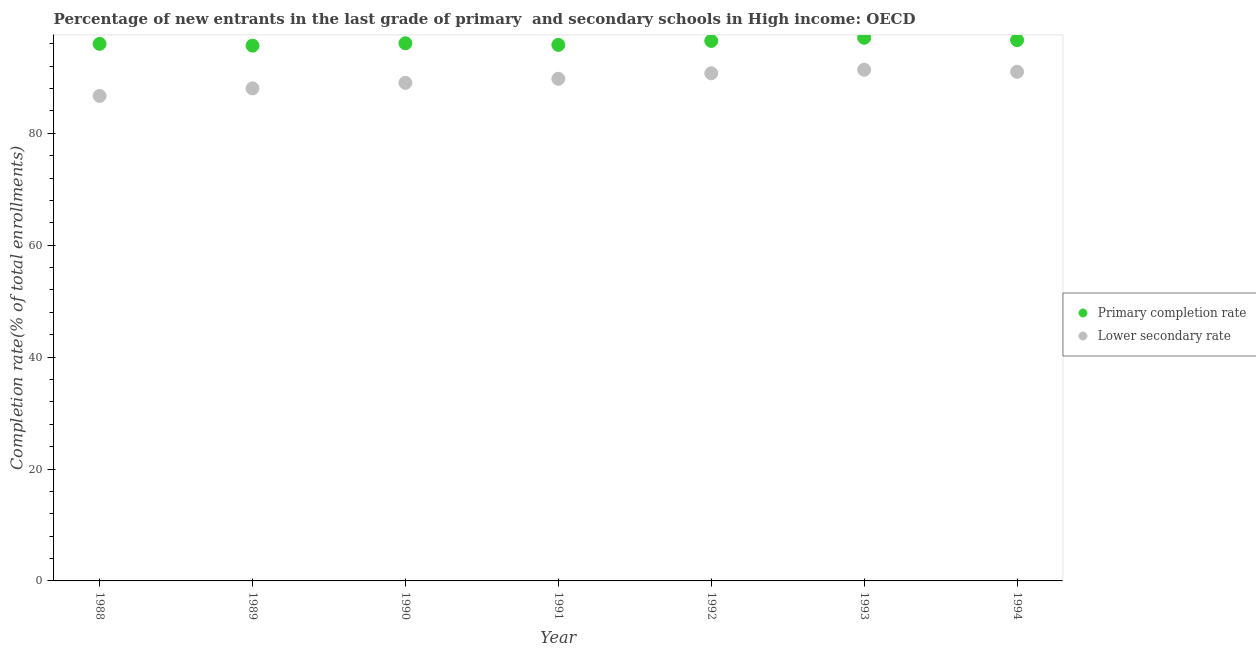What is the completion rate in primary schools in 1989?
Offer a very short reply. 95.66. Across all years, what is the maximum completion rate in secondary schools?
Offer a terse response. 91.36. Across all years, what is the minimum completion rate in primary schools?
Ensure brevity in your answer.  95.66. In which year was the completion rate in primary schools maximum?
Keep it short and to the point. 1993. What is the total completion rate in primary schools in the graph?
Your response must be concise. 673.74. What is the difference between the completion rate in primary schools in 1988 and that in 1992?
Your answer should be very brief. -0.52. What is the difference between the completion rate in primary schools in 1993 and the completion rate in secondary schools in 1990?
Your response must be concise. 8.06. What is the average completion rate in secondary schools per year?
Your answer should be compact. 89.5. In the year 1990, what is the difference between the completion rate in secondary schools and completion rate in primary schools?
Your response must be concise. -7.08. What is the ratio of the completion rate in primary schools in 1989 to that in 1993?
Make the answer very short. 0.99. Is the completion rate in secondary schools in 1990 less than that in 1992?
Your answer should be compact. Yes. Is the difference between the completion rate in secondary schools in 1991 and 1992 greater than the difference between the completion rate in primary schools in 1991 and 1992?
Offer a terse response. No. What is the difference between the highest and the second highest completion rate in primary schools?
Ensure brevity in your answer.  0.42. What is the difference between the highest and the lowest completion rate in secondary schools?
Provide a short and direct response. 4.68. In how many years, is the completion rate in primary schools greater than the average completion rate in primary schools taken over all years?
Your answer should be very brief. 3. Is the sum of the completion rate in primary schools in 1988 and 1989 greater than the maximum completion rate in secondary schools across all years?
Give a very brief answer. Yes. Does the completion rate in primary schools monotonically increase over the years?
Your response must be concise. No. Is the completion rate in primary schools strictly less than the completion rate in secondary schools over the years?
Ensure brevity in your answer.  No. How many dotlines are there?
Make the answer very short. 2. What is the difference between two consecutive major ticks on the Y-axis?
Provide a succinct answer. 20. Does the graph contain any zero values?
Give a very brief answer. No. Does the graph contain grids?
Ensure brevity in your answer.  No. How many legend labels are there?
Your response must be concise. 2. How are the legend labels stacked?
Provide a short and direct response. Vertical. What is the title of the graph?
Provide a short and direct response. Percentage of new entrants in the last grade of primary  and secondary schools in High income: OECD. What is the label or title of the Y-axis?
Offer a very short reply. Completion rate(% of total enrollments). What is the Completion rate(% of total enrollments) of Primary completion rate in 1988?
Ensure brevity in your answer.  95.98. What is the Completion rate(% of total enrollments) of Lower secondary rate in 1988?
Give a very brief answer. 86.67. What is the Completion rate(% of total enrollments) in Primary completion rate in 1989?
Your answer should be compact. 95.66. What is the Completion rate(% of total enrollments) of Lower secondary rate in 1989?
Ensure brevity in your answer.  88.02. What is the Completion rate(% of total enrollments) in Primary completion rate in 1990?
Keep it short and to the point. 96.09. What is the Completion rate(% of total enrollments) of Lower secondary rate in 1990?
Provide a short and direct response. 89.01. What is the Completion rate(% of total enrollments) of Primary completion rate in 1991?
Your answer should be compact. 95.8. What is the Completion rate(% of total enrollments) of Lower secondary rate in 1991?
Offer a terse response. 89.74. What is the Completion rate(% of total enrollments) of Primary completion rate in 1992?
Offer a very short reply. 96.5. What is the Completion rate(% of total enrollments) of Lower secondary rate in 1992?
Provide a short and direct response. 90.72. What is the Completion rate(% of total enrollments) in Primary completion rate in 1993?
Provide a short and direct response. 97.07. What is the Completion rate(% of total enrollments) of Lower secondary rate in 1993?
Keep it short and to the point. 91.36. What is the Completion rate(% of total enrollments) in Primary completion rate in 1994?
Your answer should be very brief. 96.65. What is the Completion rate(% of total enrollments) of Lower secondary rate in 1994?
Offer a very short reply. 90.99. Across all years, what is the maximum Completion rate(% of total enrollments) in Primary completion rate?
Give a very brief answer. 97.07. Across all years, what is the maximum Completion rate(% of total enrollments) in Lower secondary rate?
Your answer should be compact. 91.36. Across all years, what is the minimum Completion rate(% of total enrollments) in Primary completion rate?
Offer a very short reply. 95.66. Across all years, what is the minimum Completion rate(% of total enrollments) of Lower secondary rate?
Your response must be concise. 86.67. What is the total Completion rate(% of total enrollments) in Primary completion rate in the graph?
Your answer should be compact. 673.74. What is the total Completion rate(% of total enrollments) of Lower secondary rate in the graph?
Make the answer very short. 626.51. What is the difference between the Completion rate(% of total enrollments) of Primary completion rate in 1988 and that in 1989?
Offer a terse response. 0.32. What is the difference between the Completion rate(% of total enrollments) of Lower secondary rate in 1988 and that in 1989?
Keep it short and to the point. -1.35. What is the difference between the Completion rate(% of total enrollments) of Primary completion rate in 1988 and that in 1990?
Your response must be concise. -0.11. What is the difference between the Completion rate(% of total enrollments) of Lower secondary rate in 1988 and that in 1990?
Offer a terse response. -2.34. What is the difference between the Completion rate(% of total enrollments) of Primary completion rate in 1988 and that in 1991?
Make the answer very short. 0.18. What is the difference between the Completion rate(% of total enrollments) in Lower secondary rate in 1988 and that in 1991?
Ensure brevity in your answer.  -3.07. What is the difference between the Completion rate(% of total enrollments) of Primary completion rate in 1988 and that in 1992?
Provide a short and direct response. -0.52. What is the difference between the Completion rate(% of total enrollments) of Lower secondary rate in 1988 and that in 1992?
Give a very brief answer. -4.05. What is the difference between the Completion rate(% of total enrollments) in Primary completion rate in 1988 and that in 1993?
Offer a very short reply. -1.09. What is the difference between the Completion rate(% of total enrollments) of Lower secondary rate in 1988 and that in 1993?
Ensure brevity in your answer.  -4.68. What is the difference between the Completion rate(% of total enrollments) in Primary completion rate in 1988 and that in 1994?
Provide a succinct answer. -0.67. What is the difference between the Completion rate(% of total enrollments) in Lower secondary rate in 1988 and that in 1994?
Provide a short and direct response. -4.32. What is the difference between the Completion rate(% of total enrollments) of Primary completion rate in 1989 and that in 1990?
Ensure brevity in your answer.  -0.43. What is the difference between the Completion rate(% of total enrollments) of Lower secondary rate in 1989 and that in 1990?
Give a very brief answer. -0.99. What is the difference between the Completion rate(% of total enrollments) of Primary completion rate in 1989 and that in 1991?
Offer a very short reply. -0.14. What is the difference between the Completion rate(% of total enrollments) of Lower secondary rate in 1989 and that in 1991?
Your response must be concise. -1.72. What is the difference between the Completion rate(% of total enrollments) of Primary completion rate in 1989 and that in 1992?
Give a very brief answer. -0.84. What is the difference between the Completion rate(% of total enrollments) in Lower secondary rate in 1989 and that in 1992?
Provide a succinct answer. -2.7. What is the difference between the Completion rate(% of total enrollments) in Primary completion rate in 1989 and that in 1993?
Make the answer very short. -1.41. What is the difference between the Completion rate(% of total enrollments) of Lower secondary rate in 1989 and that in 1993?
Offer a very short reply. -3.34. What is the difference between the Completion rate(% of total enrollments) in Primary completion rate in 1989 and that in 1994?
Ensure brevity in your answer.  -0.99. What is the difference between the Completion rate(% of total enrollments) in Lower secondary rate in 1989 and that in 1994?
Ensure brevity in your answer.  -2.97. What is the difference between the Completion rate(% of total enrollments) of Primary completion rate in 1990 and that in 1991?
Provide a short and direct response. 0.29. What is the difference between the Completion rate(% of total enrollments) of Lower secondary rate in 1990 and that in 1991?
Your response must be concise. -0.73. What is the difference between the Completion rate(% of total enrollments) of Primary completion rate in 1990 and that in 1992?
Your answer should be compact. -0.41. What is the difference between the Completion rate(% of total enrollments) of Lower secondary rate in 1990 and that in 1992?
Make the answer very short. -1.71. What is the difference between the Completion rate(% of total enrollments) in Primary completion rate in 1990 and that in 1993?
Offer a very short reply. -0.98. What is the difference between the Completion rate(% of total enrollments) of Lower secondary rate in 1990 and that in 1993?
Ensure brevity in your answer.  -2.35. What is the difference between the Completion rate(% of total enrollments) in Primary completion rate in 1990 and that in 1994?
Make the answer very short. -0.56. What is the difference between the Completion rate(% of total enrollments) in Lower secondary rate in 1990 and that in 1994?
Your answer should be very brief. -1.98. What is the difference between the Completion rate(% of total enrollments) of Primary completion rate in 1991 and that in 1992?
Keep it short and to the point. -0.71. What is the difference between the Completion rate(% of total enrollments) of Lower secondary rate in 1991 and that in 1992?
Offer a very short reply. -0.98. What is the difference between the Completion rate(% of total enrollments) in Primary completion rate in 1991 and that in 1993?
Provide a short and direct response. -1.27. What is the difference between the Completion rate(% of total enrollments) of Lower secondary rate in 1991 and that in 1993?
Keep it short and to the point. -1.62. What is the difference between the Completion rate(% of total enrollments) of Primary completion rate in 1991 and that in 1994?
Ensure brevity in your answer.  -0.85. What is the difference between the Completion rate(% of total enrollments) in Lower secondary rate in 1991 and that in 1994?
Ensure brevity in your answer.  -1.25. What is the difference between the Completion rate(% of total enrollments) of Primary completion rate in 1992 and that in 1993?
Make the answer very short. -0.56. What is the difference between the Completion rate(% of total enrollments) of Lower secondary rate in 1992 and that in 1993?
Provide a short and direct response. -0.64. What is the difference between the Completion rate(% of total enrollments) in Primary completion rate in 1992 and that in 1994?
Ensure brevity in your answer.  -0.14. What is the difference between the Completion rate(% of total enrollments) of Lower secondary rate in 1992 and that in 1994?
Provide a short and direct response. -0.27. What is the difference between the Completion rate(% of total enrollments) in Primary completion rate in 1993 and that in 1994?
Provide a short and direct response. 0.42. What is the difference between the Completion rate(% of total enrollments) of Lower secondary rate in 1993 and that in 1994?
Your answer should be compact. 0.37. What is the difference between the Completion rate(% of total enrollments) of Primary completion rate in 1988 and the Completion rate(% of total enrollments) of Lower secondary rate in 1989?
Ensure brevity in your answer.  7.96. What is the difference between the Completion rate(% of total enrollments) in Primary completion rate in 1988 and the Completion rate(% of total enrollments) in Lower secondary rate in 1990?
Make the answer very short. 6.97. What is the difference between the Completion rate(% of total enrollments) in Primary completion rate in 1988 and the Completion rate(% of total enrollments) in Lower secondary rate in 1991?
Offer a very short reply. 6.24. What is the difference between the Completion rate(% of total enrollments) in Primary completion rate in 1988 and the Completion rate(% of total enrollments) in Lower secondary rate in 1992?
Your response must be concise. 5.26. What is the difference between the Completion rate(% of total enrollments) in Primary completion rate in 1988 and the Completion rate(% of total enrollments) in Lower secondary rate in 1993?
Make the answer very short. 4.62. What is the difference between the Completion rate(% of total enrollments) in Primary completion rate in 1988 and the Completion rate(% of total enrollments) in Lower secondary rate in 1994?
Offer a very short reply. 4.99. What is the difference between the Completion rate(% of total enrollments) in Primary completion rate in 1989 and the Completion rate(% of total enrollments) in Lower secondary rate in 1990?
Provide a succinct answer. 6.65. What is the difference between the Completion rate(% of total enrollments) of Primary completion rate in 1989 and the Completion rate(% of total enrollments) of Lower secondary rate in 1991?
Keep it short and to the point. 5.92. What is the difference between the Completion rate(% of total enrollments) of Primary completion rate in 1989 and the Completion rate(% of total enrollments) of Lower secondary rate in 1992?
Make the answer very short. 4.94. What is the difference between the Completion rate(% of total enrollments) of Primary completion rate in 1989 and the Completion rate(% of total enrollments) of Lower secondary rate in 1993?
Your response must be concise. 4.3. What is the difference between the Completion rate(% of total enrollments) of Primary completion rate in 1989 and the Completion rate(% of total enrollments) of Lower secondary rate in 1994?
Ensure brevity in your answer.  4.67. What is the difference between the Completion rate(% of total enrollments) in Primary completion rate in 1990 and the Completion rate(% of total enrollments) in Lower secondary rate in 1991?
Make the answer very short. 6.35. What is the difference between the Completion rate(% of total enrollments) in Primary completion rate in 1990 and the Completion rate(% of total enrollments) in Lower secondary rate in 1992?
Your response must be concise. 5.37. What is the difference between the Completion rate(% of total enrollments) in Primary completion rate in 1990 and the Completion rate(% of total enrollments) in Lower secondary rate in 1993?
Keep it short and to the point. 4.73. What is the difference between the Completion rate(% of total enrollments) in Primary completion rate in 1990 and the Completion rate(% of total enrollments) in Lower secondary rate in 1994?
Keep it short and to the point. 5.1. What is the difference between the Completion rate(% of total enrollments) of Primary completion rate in 1991 and the Completion rate(% of total enrollments) of Lower secondary rate in 1992?
Provide a succinct answer. 5.08. What is the difference between the Completion rate(% of total enrollments) in Primary completion rate in 1991 and the Completion rate(% of total enrollments) in Lower secondary rate in 1993?
Make the answer very short. 4.44. What is the difference between the Completion rate(% of total enrollments) of Primary completion rate in 1991 and the Completion rate(% of total enrollments) of Lower secondary rate in 1994?
Your answer should be very brief. 4.81. What is the difference between the Completion rate(% of total enrollments) in Primary completion rate in 1992 and the Completion rate(% of total enrollments) in Lower secondary rate in 1993?
Offer a very short reply. 5.15. What is the difference between the Completion rate(% of total enrollments) in Primary completion rate in 1992 and the Completion rate(% of total enrollments) in Lower secondary rate in 1994?
Ensure brevity in your answer.  5.51. What is the difference between the Completion rate(% of total enrollments) in Primary completion rate in 1993 and the Completion rate(% of total enrollments) in Lower secondary rate in 1994?
Give a very brief answer. 6.07. What is the average Completion rate(% of total enrollments) of Primary completion rate per year?
Keep it short and to the point. 96.25. What is the average Completion rate(% of total enrollments) in Lower secondary rate per year?
Provide a short and direct response. 89.5. In the year 1988, what is the difference between the Completion rate(% of total enrollments) of Primary completion rate and Completion rate(% of total enrollments) of Lower secondary rate?
Keep it short and to the point. 9.31. In the year 1989, what is the difference between the Completion rate(% of total enrollments) in Primary completion rate and Completion rate(% of total enrollments) in Lower secondary rate?
Provide a short and direct response. 7.64. In the year 1990, what is the difference between the Completion rate(% of total enrollments) of Primary completion rate and Completion rate(% of total enrollments) of Lower secondary rate?
Your response must be concise. 7.08. In the year 1991, what is the difference between the Completion rate(% of total enrollments) in Primary completion rate and Completion rate(% of total enrollments) in Lower secondary rate?
Give a very brief answer. 6.06. In the year 1992, what is the difference between the Completion rate(% of total enrollments) of Primary completion rate and Completion rate(% of total enrollments) of Lower secondary rate?
Offer a very short reply. 5.78. In the year 1993, what is the difference between the Completion rate(% of total enrollments) in Primary completion rate and Completion rate(% of total enrollments) in Lower secondary rate?
Provide a short and direct response. 5.71. In the year 1994, what is the difference between the Completion rate(% of total enrollments) in Primary completion rate and Completion rate(% of total enrollments) in Lower secondary rate?
Your answer should be compact. 5.66. What is the ratio of the Completion rate(% of total enrollments) in Primary completion rate in 1988 to that in 1989?
Make the answer very short. 1. What is the ratio of the Completion rate(% of total enrollments) in Lower secondary rate in 1988 to that in 1989?
Your answer should be compact. 0.98. What is the ratio of the Completion rate(% of total enrollments) in Primary completion rate in 1988 to that in 1990?
Keep it short and to the point. 1. What is the ratio of the Completion rate(% of total enrollments) in Lower secondary rate in 1988 to that in 1990?
Keep it short and to the point. 0.97. What is the ratio of the Completion rate(% of total enrollments) in Primary completion rate in 1988 to that in 1991?
Give a very brief answer. 1. What is the ratio of the Completion rate(% of total enrollments) in Lower secondary rate in 1988 to that in 1991?
Make the answer very short. 0.97. What is the ratio of the Completion rate(% of total enrollments) in Lower secondary rate in 1988 to that in 1992?
Offer a very short reply. 0.96. What is the ratio of the Completion rate(% of total enrollments) of Lower secondary rate in 1988 to that in 1993?
Offer a terse response. 0.95. What is the ratio of the Completion rate(% of total enrollments) of Primary completion rate in 1988 to that in 1994?
Ensure brevity in your answer.  0.99. What is the ratio of the Completion rate(% of total enrollments) in Lower secondary rate in 1988 to that in 1994?
Offer a terse response. 0.95. What is the ratio of the Completion rate(% of total enrollments) in Lower secondary rate in 1989 to that in 1990?
Make the answer very short. 0.99. What is the ratio of the Completion rate(% of total enrollments) in Primary completion rate in 1989 to that in 1991?
Make the answer very short. 1. What is the ratio of the Completion rate(% of total enrollments) of Lower secondary rate in 1989 to that in 1991?
Your response must be concise. 0.98. What is the ratio of the Completion rate(% of total enrollments) in Lower secondary rate in 1989 to that in 1992?
Keep it short and to the point. 0.97. What is the ratio of the Completion rate(% of total enrollments) in Primary completion rate in 1989 to that in 1993?
Ensure brevity in your answer.  0.99. What is the ratio of the Completion rate(% of total enrollments) of Lower secondary rate in 1989 to that in 1993?
Provide a short and direct response. 0.96. What is the ratio of the Completion rate(% of total enrollments) in Lower secondary rate in 1989 to that in 1994?
Offer a terse response. 0.97. What is the ratio of the Completion rate(% of total enrollments) of Primary completion rate in 1990 to that in 1991?
Your answer should be compact. 1. What is the ratio of the Completion rate(% of total enrollments) of Primary completion rate in 1990 to that in 1992?
Provide a short and direct response. 1. What is the ratio of the Completion rate(% of total enrollments) in Lower secondary rate in 1990 to that in 1992?
Offer a terse response. 0.98. What is the ratio of the Completion rate(% of total enrollments) of Primary completion rate in 1990 to that in 1993?
Offer a very short reply. 0.99. What is the ratio of the Completion rate(% of total enrollments) in Lower secondary rate in 1990 to that in 1993?
Offer a terse response. 0.97. What is the ratio of the Completion rate(% of total enrollments) in Primary completion rate in 1990 to that in 1994?
Keep it short and to the point. 0.99. What is the ratio of the Completion rate(% of total enrollments) of Lower secondary rate in 1990 to that in 1994?
Give a very brief answer. 0.98. What is the ratio of the Completion rate(% of total enrollments) in Primary completion rate in 1991 to that in 1993?
Keep it short and to the point. 0.99. What is the ratio of the Completion rate(% of total enrollments) in Lower secondary rate in 1991 to that in 1993?
Provide a short and direct response. 0.98. What is the ratio of the Completion rate(% of total enrollments) in Primary completion rate in 1991 to that in 1994?
Ensure brevity in your answer.  0.99. What is the ratio of the Completion rate(% of total enrollments) in Lower secondary rate in 1991 to that in 1994?
Your response must be concise. 0.99. What is the ratio of the Completion rate(% of total enrollments) in Primary completion rate in 1992 to that in 1993?
Ensure brevity in your answer.  0.99. What is the ratio of the Completion rate(% of total enrollments) of Lower secondary rate in 1992 to that in 1994?
Offer a very short reply. 1. What is the difference between the highest and the second highest Completion rate(% of total enrollments) of Primary completion rate?
Your answer should be very brief. 0.42. What is the difference between the highest and the second highest Completion rate(% of total enrollments) in Lower secondary rate?
Provide a short and direct response. 0.37. What is the difference between the highest and the lowest Completion rate(% of total enrollments) in Primary completion rate?
Keep it short and to the point. 1.41. What is the difference between the highest and the lowest Completion rate(% of total enrollments) of Lower secondary rate?
Offer a terse response. 4.68. 